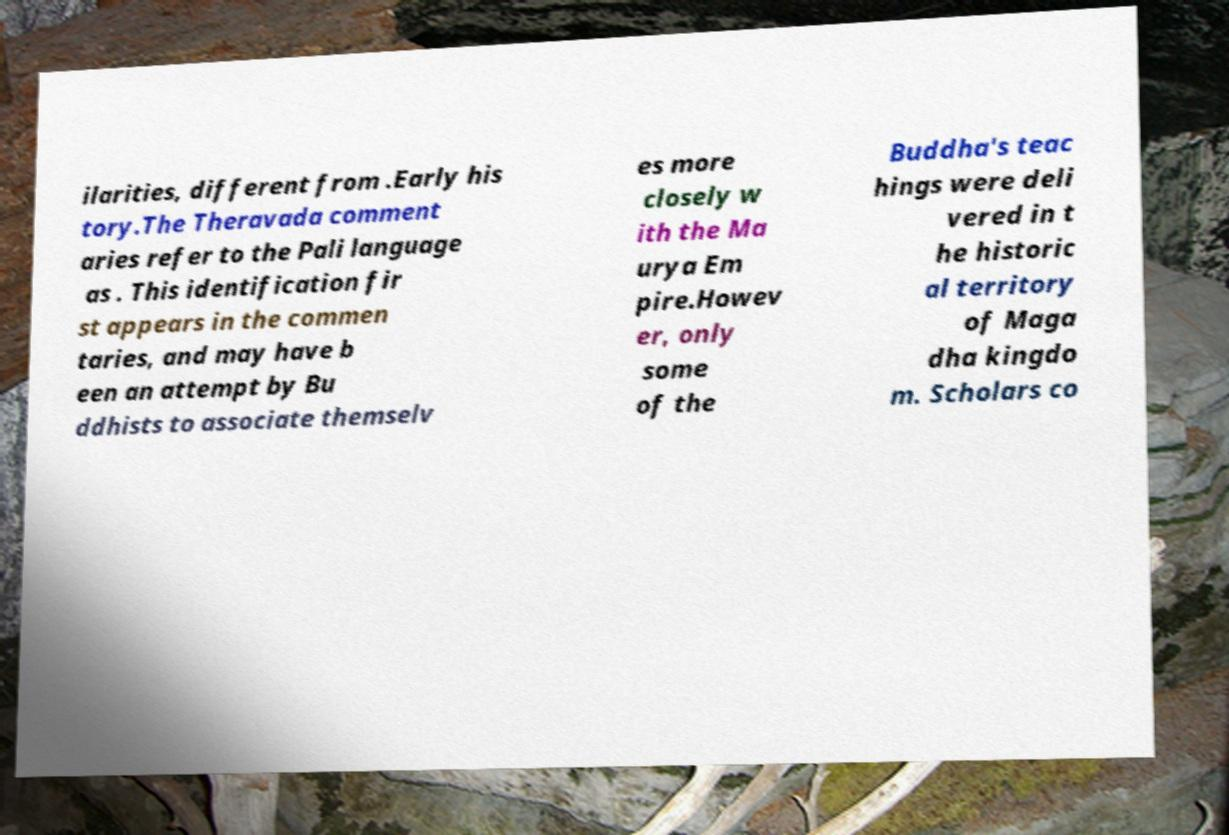There's text embedded in this image that I need extracted. Can you transcribe it verbatim? ilarities, different from .Early his tory.The Theravada comment aries refer to the Pali language as . This identification fir st appears in the commen taries, and may have b een an attempt by Bu ddhists to associate themselv es more closely w ith the Ma urya Em pire.Howev er, only some of the Buddha's teac hings were deli vered in t he historic al territory of Maga dha kingdo m. Scholars co 